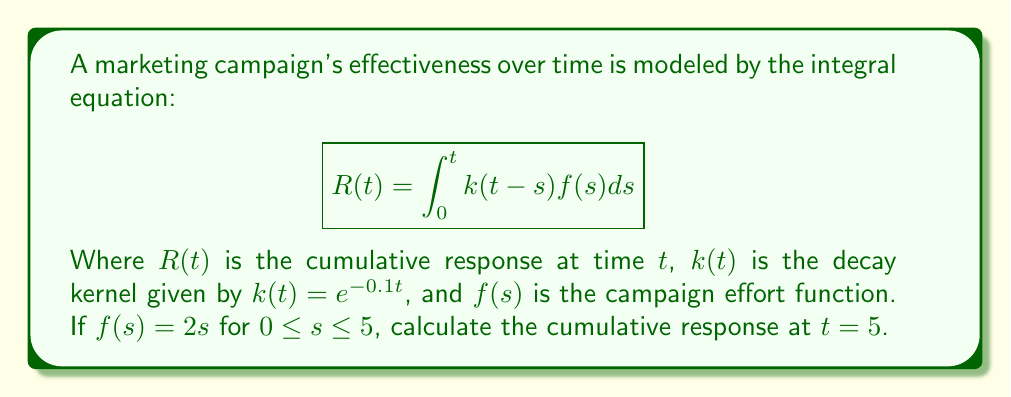Help me with this question. 1) We start with the given integral equation:
   $$R(t) = \int_0^t k(t-s)f(s)ds$$

2) Substitute the given functions:
   $k(t) = e^{-0.1t}$
   $f(s) = 2s$ for $0 \leq s \leq 5$

3) Our integral becomes:
   $$R(5) = \int_0^5 e^{-0.1(5-s)}(2s)ds$$

4) Simplify the integrand:
   $$R(5) = 2e^{-0.5}\int_0^5 se^{0.1s}ds$$

5) To solve this, we use integration by parts. Let $u = s$ and $dv = e^{0.1s}ds$:
   $$R(5) = 2e^{-0.5}\left[\frac{s}{0.1}e^{0.1s}\bigg|_0^5 - \int_0^5 \frac{1}{0.1}e^{0.1s}ds\right]$$

6) Evaluate the integral:
   $$R(5) = 2e^{-0.5}\left[\frac{5}{0.1}e^{0.5} - \frac{1}{0.1^2}e^{0.5} + \frac{1}{0.1^2}\right]$$

7) Simplify:
   $$R(5) = 2e^{-0.5}\left[50e^{0.5} - 100e^{0.5} + 100\right]$$
   $$R(5) = 2e^{-0.5}\left[-50e^{0.5} + 100\right]$$
   $$R(5) = -100 + 200e^{-0.5}$$

8) Calculate the final value:
   $$R(5) \approx 21.47$$
Answer: 21.47 